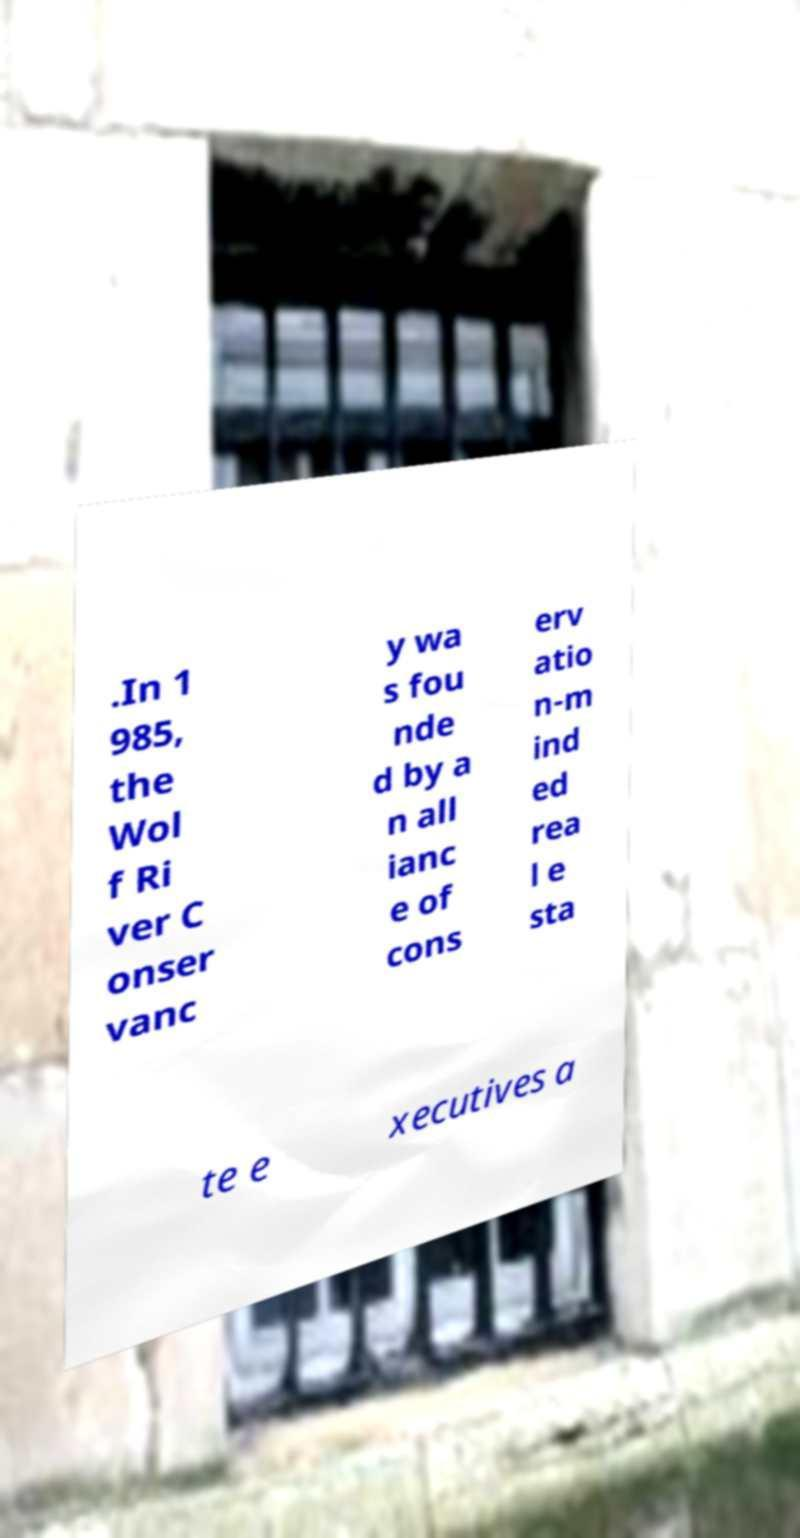Can you accurately transcribe the text from the provided image for me? .In 1 985, the Wol f Ri ver C onser vanc y wa s fou nde d by a n all ianc e of cons erv atio n-m ind ed rea l e sta te e xecutives a 